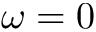Convert formula to latex. <formula><loc_0><loc_0><loc_500><loc_500>\omega = 0</formula> 